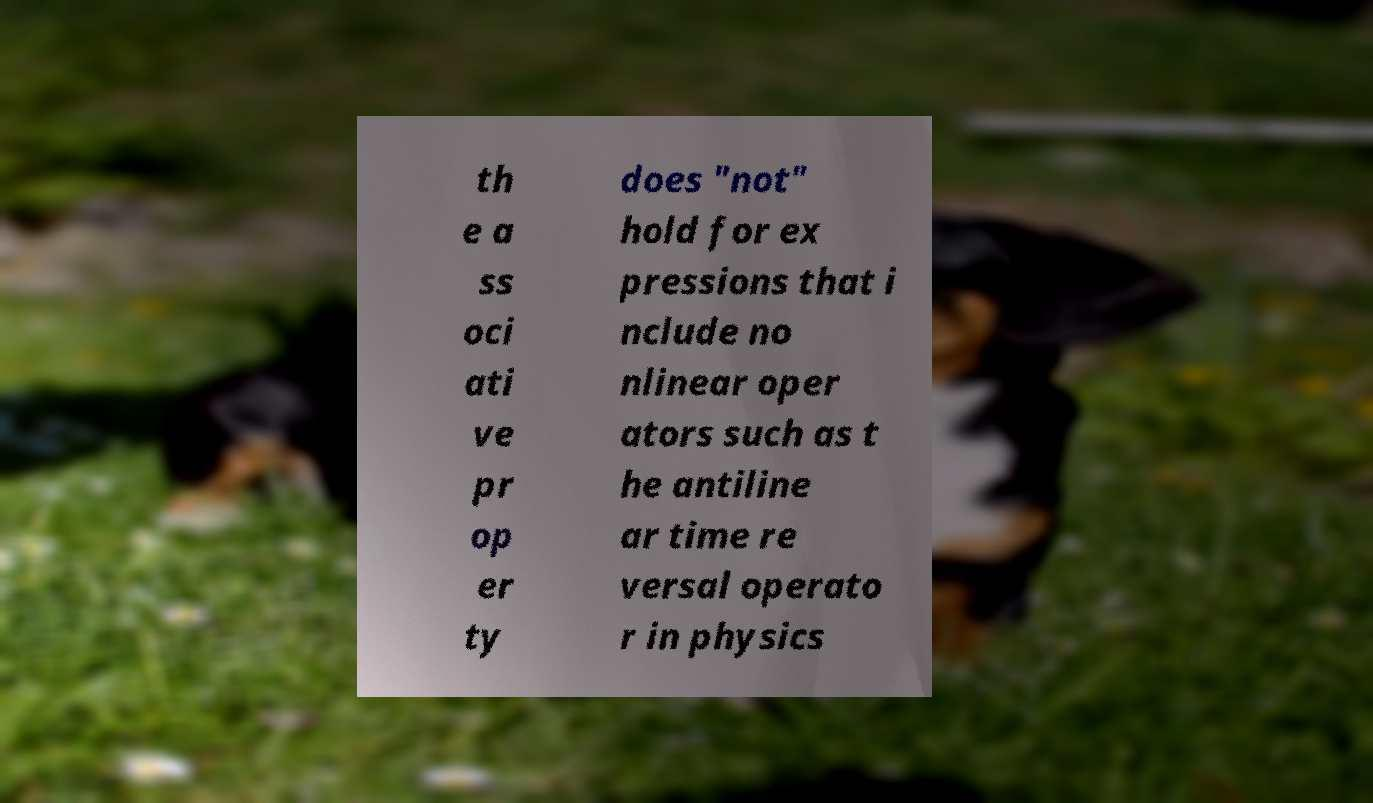Please read and relay the text visible in this image. What does it say? th e a ss oci ati ve pr op er ty does "not" hold for ex pressions that i nclude no nlinear oper ators such as t he antiline ar time re versal operato r in physics 